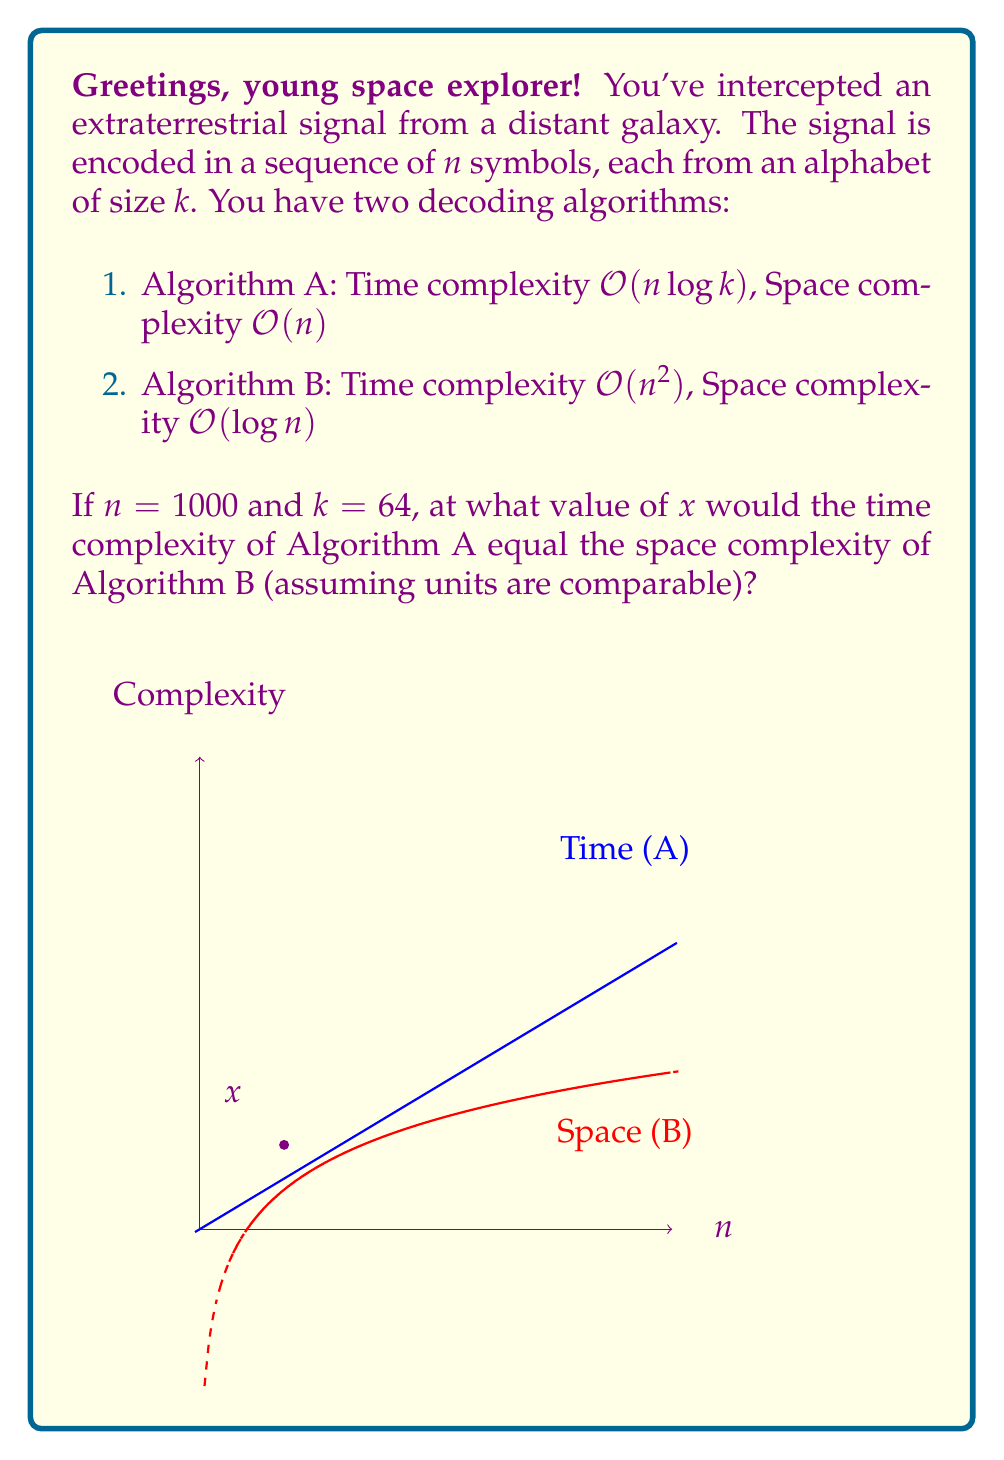Help me with this question. Let's approach this step-by-step:

1) First, we need to express the time complexity of Algorithm A and the space complexity of Algorithm B in terms of $n$:

   Algorithm A (time): $O(n \log k)$
   Algorithm B (space): $O(\log n)$

2) We want to find where these are equal, so we set up the equation:

   $n \log k = \log n$

3) Given that $k = 64$, we can simplify:

   $n \log 64 = \log n$

4) $\log 64 = 6$ (since $2^6 = 64$), so our equation becomes:

   $6n = \log n$

5) To solve this, we need to use the Lambert W function, which is defined as the inverse function of $f(x) = xe^x$. The solution to our equation is:

   $n = \frac{W(6)}{6}$

6) Using a calculator or computer algebra system, we can evaluate this:

   $\frac{W(6)}{6} \approx 178.5$

7) Therefore, the time complexity of Algorithm A equals the space complexity of Algorithm B when $n \approx 178.5$.

8) Checking our result:
   For $n = 178.5$:
   Algorithm A (time): $178.5 \log 64 \approx 1071$
   Algorithm B (space): $\log 178.5 \approx 7.48$

   The units are not directly comparable, but the ratio between them is what we're interested in.
Answer: $x \approx 178.5$ 